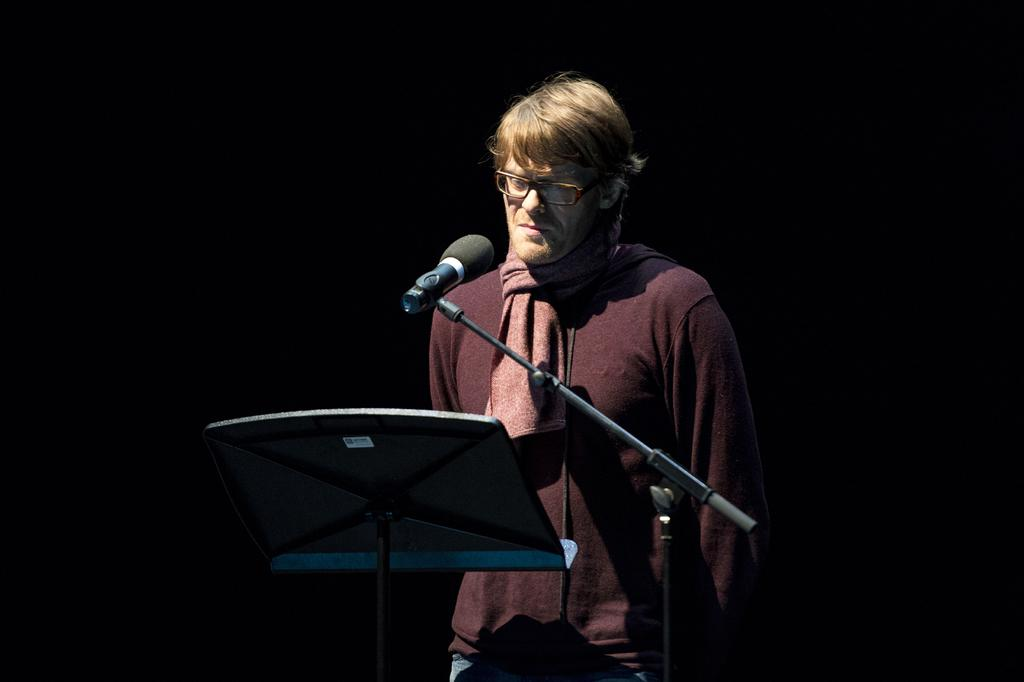What is the main subject of the image? There is a man standing in the image. What object is visible near the man? There is a microphone (mile) in the image. How is the microphone positioned in the image? The microphone is attached to a stand. What might be the purpose of the stand in the image? The stand might be for musical purposes. What can be observed about the background of the image? The background of the image appears dark. Reasoning: Let's think step by following the steps to produce the conversation. We start by identifying the main subject in the image, which is the man standing. Then, we describe the object near the man, which is the microphone. We mention the position of the microphone by stating that it is attached to a stand. Next, we speculate about the purpose of the stand, suggesting it might be for musical purposes. Finally, we describe the background of the image, noting that it appears dark. Absurd Question/Answer: What type of mask can be seen on the man in the image? There is no mask visible on the man in the image. Can you describe the cemetery in the background of the image? There is no cemetery present in the image; the background appears dark. What type of mask can be seen on the man in the image? There is no mask visible on the man in the image. Can you describe the cemetery in the background of the image? There is no cemetery present in the image; the background appears dark. 